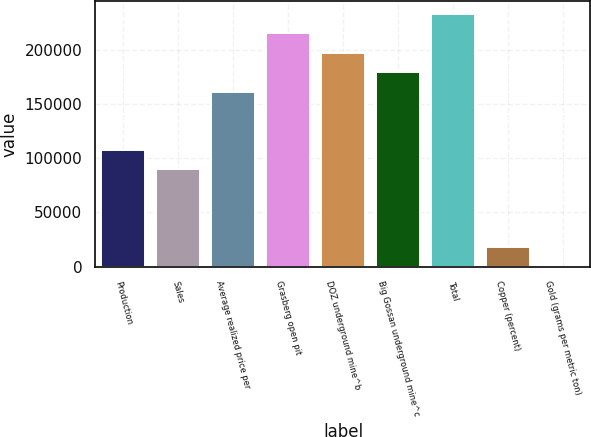<chart> <loc_0><loc_0><loc_500><loc_500><bar_chart><fcel>Production<fcel>Sales<fcel>Average realized price per<fcel>Grasberg open pit<fcel>DOZ underground mine^b<fcel>Big Gossan underground mine^c<fcel>Total<fcel>Copper (percent)<fcel>Gold (grams per metric ton)<nl><fcel>107520<fcel>89600.3<fcel>161280<fcel>215040<fcel>197120<fcel>179200<fcel>232960<fcel>17920.6<fcel>0.69<nl></chart> 